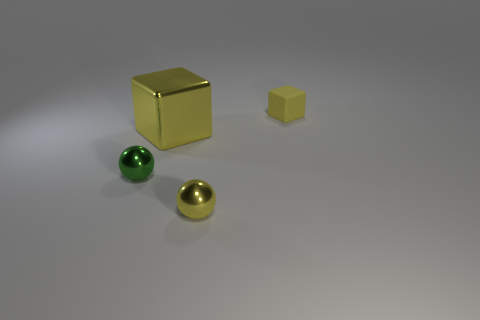Is there any other thing that is made of the same material as the small yellow cube?
Provide a short and direct response. No. Are any tiny things visible?
Provide a succinct answer. Yes. How many other objects are the same material as the small block?
Keep it short and to the point. 0. What is the material of the block that is the same size as the green shiny sphere?
Give a very brief answer. Rubber. Do the yellow object that is right of the tiny yellow sphere and the big yellow metal thing have the same shape?
Give a very brief answer. Yes. What number of objects are blocks that are on the left side of the tiny cube or cyan matte cubes?
Give a very brief answer. 1. There is a rubber thing that is the same size as the green metallic ball; what is its shape?
Keep it short and to the point. Cube. Is the size of the cube that is in front of the small yellow matte block the same as the ball in front of the tiny green sphere?
Provide a short and direct response. No. What color is the tiny sphere that is the same material as the small green thing?
Your answer should be compact. Yellow. Does the yellow cube in front of the small matte cube have the same material as the small yellow object that is behind the small green object?
Give a very brief answer. No. 